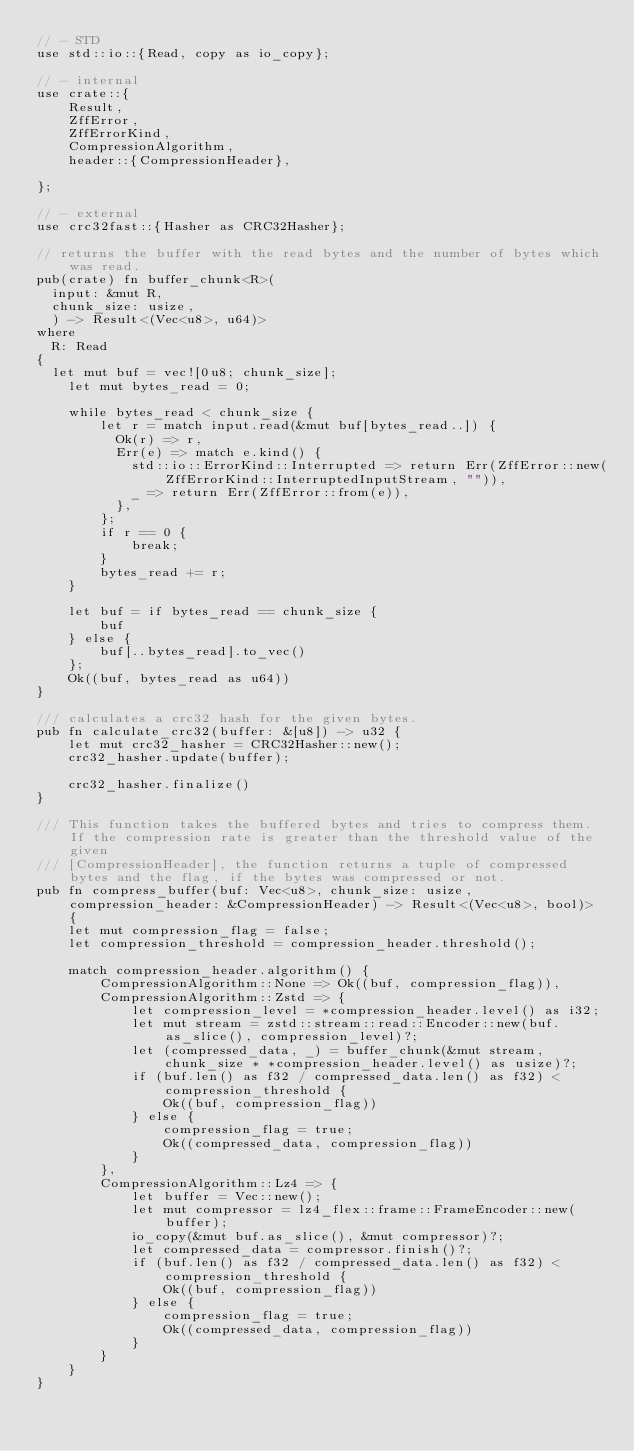<code> <loc_0><loc_0><loc_500><loc_500><_Rust_>// - STD
use std::io::{Read, copy as io_copy};

// - internal
use crate::{
    Result,
    ZffError,
    ZffErrorKind,
    CompressionAlgorithm,
    header::{CompressionHeader},

};

// - external
use crc32fast::{Hasher as CRC32Hasher};

// returns the buffer with the read bytes and the number of bytes which was read.
pub(crate) fn buffer_chunk<R>(
	input: &mut R,
	chunk_size: usize,
	) -> Result<(Vec<u8>, u64)> 
where
	R: Read
{
	let mut buf = vec![0u8; chunk_size];
    let mut bytes_read = 0;

    while bytes_read < chunk_size {
        let r = match input.read(&mut buf[bytes_read..]) {
        	Ok(r) => r,
        	Err(e) => match e.kind() {
        		std::io::ErrorKind::Interrupted => return Err(ZffError::new(ZffErrorKind::InterruptedInputStream, "")),
        		_ => return Err(ZffError::from(e)),
        	},
        };
        if r == 0 {
            break;
        }
        bytes_read += r;
    }

    let buf = if bytes_read == chunk_size {
        buf
    } else {
        buf[..bytes_read].to_vec()
    };
    Ok((buf, bytes_read as u64))
}

/// calculates a crc32 hash for the given bytes.
pub fn calculate_crc32(buffer: &[u8]) -> u32 {
    let mut crc32_hasher = CRC32Hasher::new();
    crc32_hasher.update(buffer);
    
    crc32_hasher.finalize()
}

/// This function takes the buffered bytes and tries to compress them. If the compression rate is greater than the threshold value of the given
/// [CompressionHeader], the function returns a tuple of compressed bytes and the flag, if the bytes was compressed or not.
pub fn compress_buffer(buf: Vec<u8>, chunk_size: usize, compression_header: &CompressionHeader) -> Result<(Vec<u8>, bool)> {
    let mut compression_flag = false;
    let compression_threshold = compression_header.threshold();

    match compression_header.algorithm() {
        CompressionAlgorithm::None => Ok((buf, compression_flag)),
        CompressionAlgorithm::Zstd => {
            let compression_level = *compression_header.level() as i32;
            let mut stream = zstd::stream::read::Encoder::new(buf.as_slice(), compression_level)?;
            let (compressed_data, _) = buffer_chunk(&mut stream, chunk_size * *compression_header.level() as usize)?;
            if (buf.len() as f32 / compressed_data.len() as f32) < compression_threshold {
                Ok((buf, compression_flag))
            } else {
                compression_flag = true;
                Ok((compressed_data, compression_flag))
            }
        },
        CompressionAlgorithm::Lz4 => {
            let buffer = Vec::new();
            let mut compressor = lz4_flex::frame::FrameEncoder::new(buffer);
            io_copy(&mut buf.as_slice(), &mut compressor)?;
            let compressed_data = compressor.finish()?;
            if (buf.len() as f32 / compressed_data.len() as f32) < compression_threshold {
                Ok((buf, compression_flag))
            } else {
                compression_flag = true;
                Ok((compressed_data, compression_flag))
            }
        }
    }
}</code> 